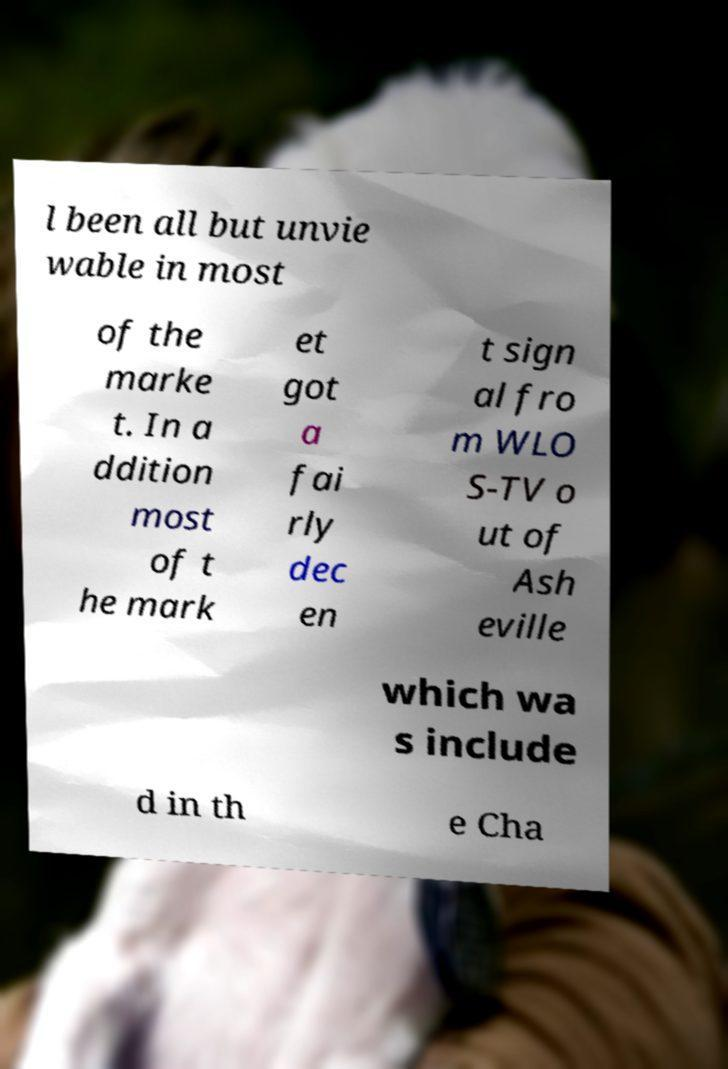Please identify and transcribe the text found in this image. l been all but unvie wable in most of the marke t. In a ddition most of t he mark et got a fai rly dec en t sign al fro m WLO S-TV o ut of Ash eville which wa s include d in th e Cha 